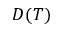Convert formula to latex. <formula><loc_0><loc_0><loc_500><loc_500>D ( T )</formula> 